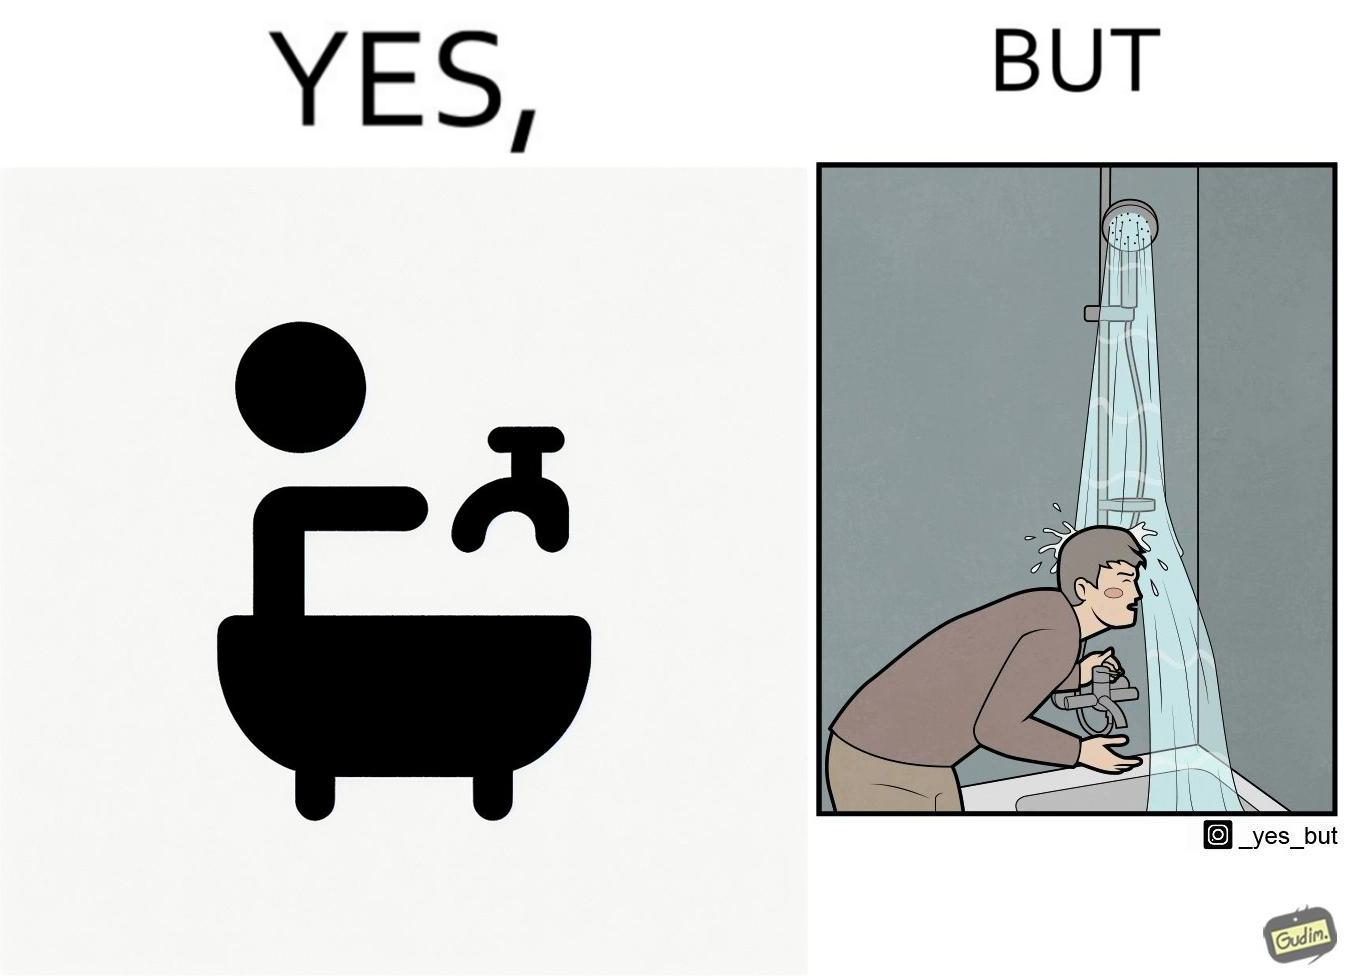Explain why this image is satirical. The image is funny, as the person is trying to operate the tap, but water comes out of the handheld shower resting on a holder instead of the tap, making the person drenched in water. 